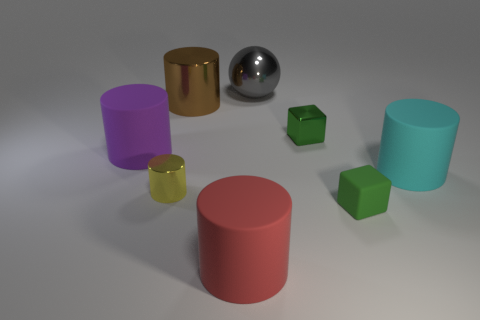Subtract all cyan cylinders. How many cylinders are left? 4 Subtract all purple cylinders. How many cylinders are left? 4 Subtract all gray cylinders. Subtract all brown cubes. How many cylinders are left? 5 Add 2 tiny rubber spheres. How many objects exist? 10 Subtract all cubes. How many objects are left? 6 Add 4 small green matte blocks. How many small green matte blocks exist? 5 Subtract 0 purple blocks. How many objects are left? 8 Subtract all big brown metal things. Subtract all metallic spheres. How many objects are left? 6 Add 6 small cubes. How many small cubes are left? 8 